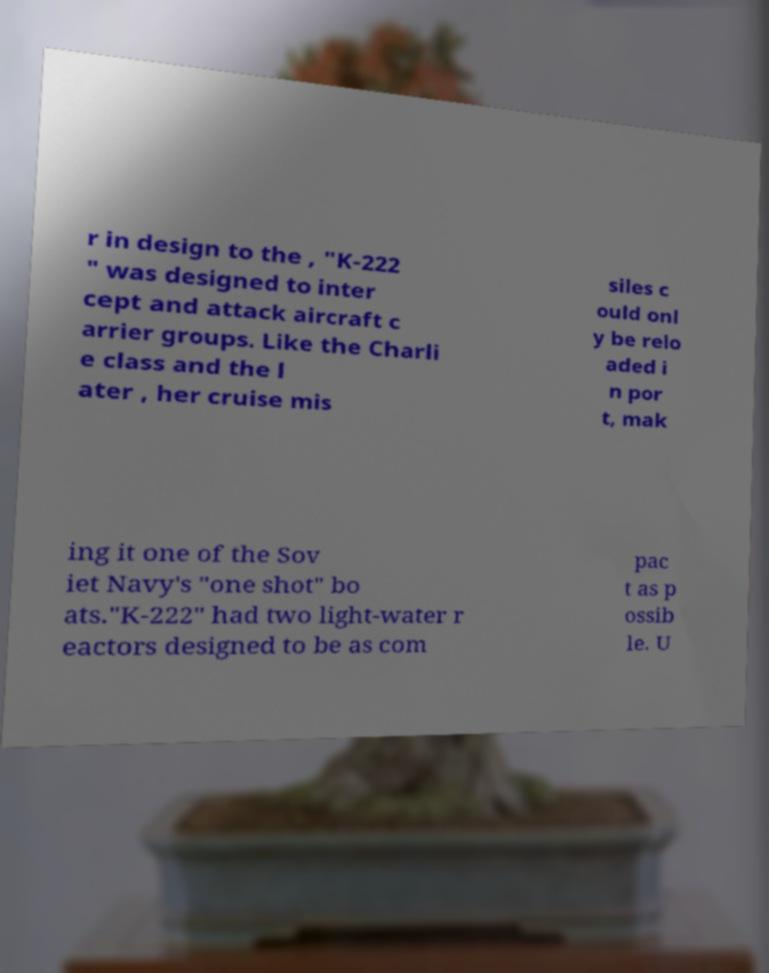Please read and relay the text visible in this image. What does it say? r in design to the , "K-222 " was designed to inter cept and attack aircraft c arrier groups. Like the Charli e class and the l ater , her cruise mis siles c ould onl y be relo aded i n por t, mak ing it one of the Sov iet Navy's "one shot" bo ats."K-222" had two light-water r eactors designed to be as com pac t as p ossib le. U 